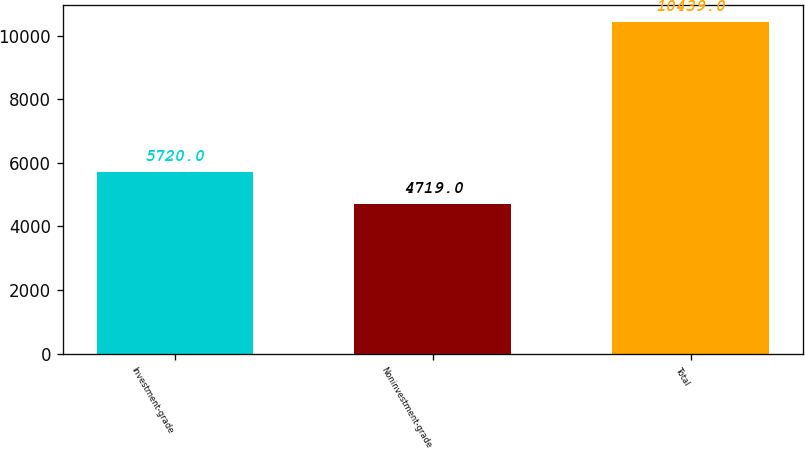<chart> <loc_0><loc_0><loc_500><loc_500><bar_chart><fcel>Investment-grade<fcel>Noninvestment-grade<fcel>Total<nl><fcel>5720<fcel>4719<fcel>10439<nl></chart> 